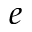Convert formula to latex. <formula><loc_0><loc_0><loc_500><loc_500>e</formula> 